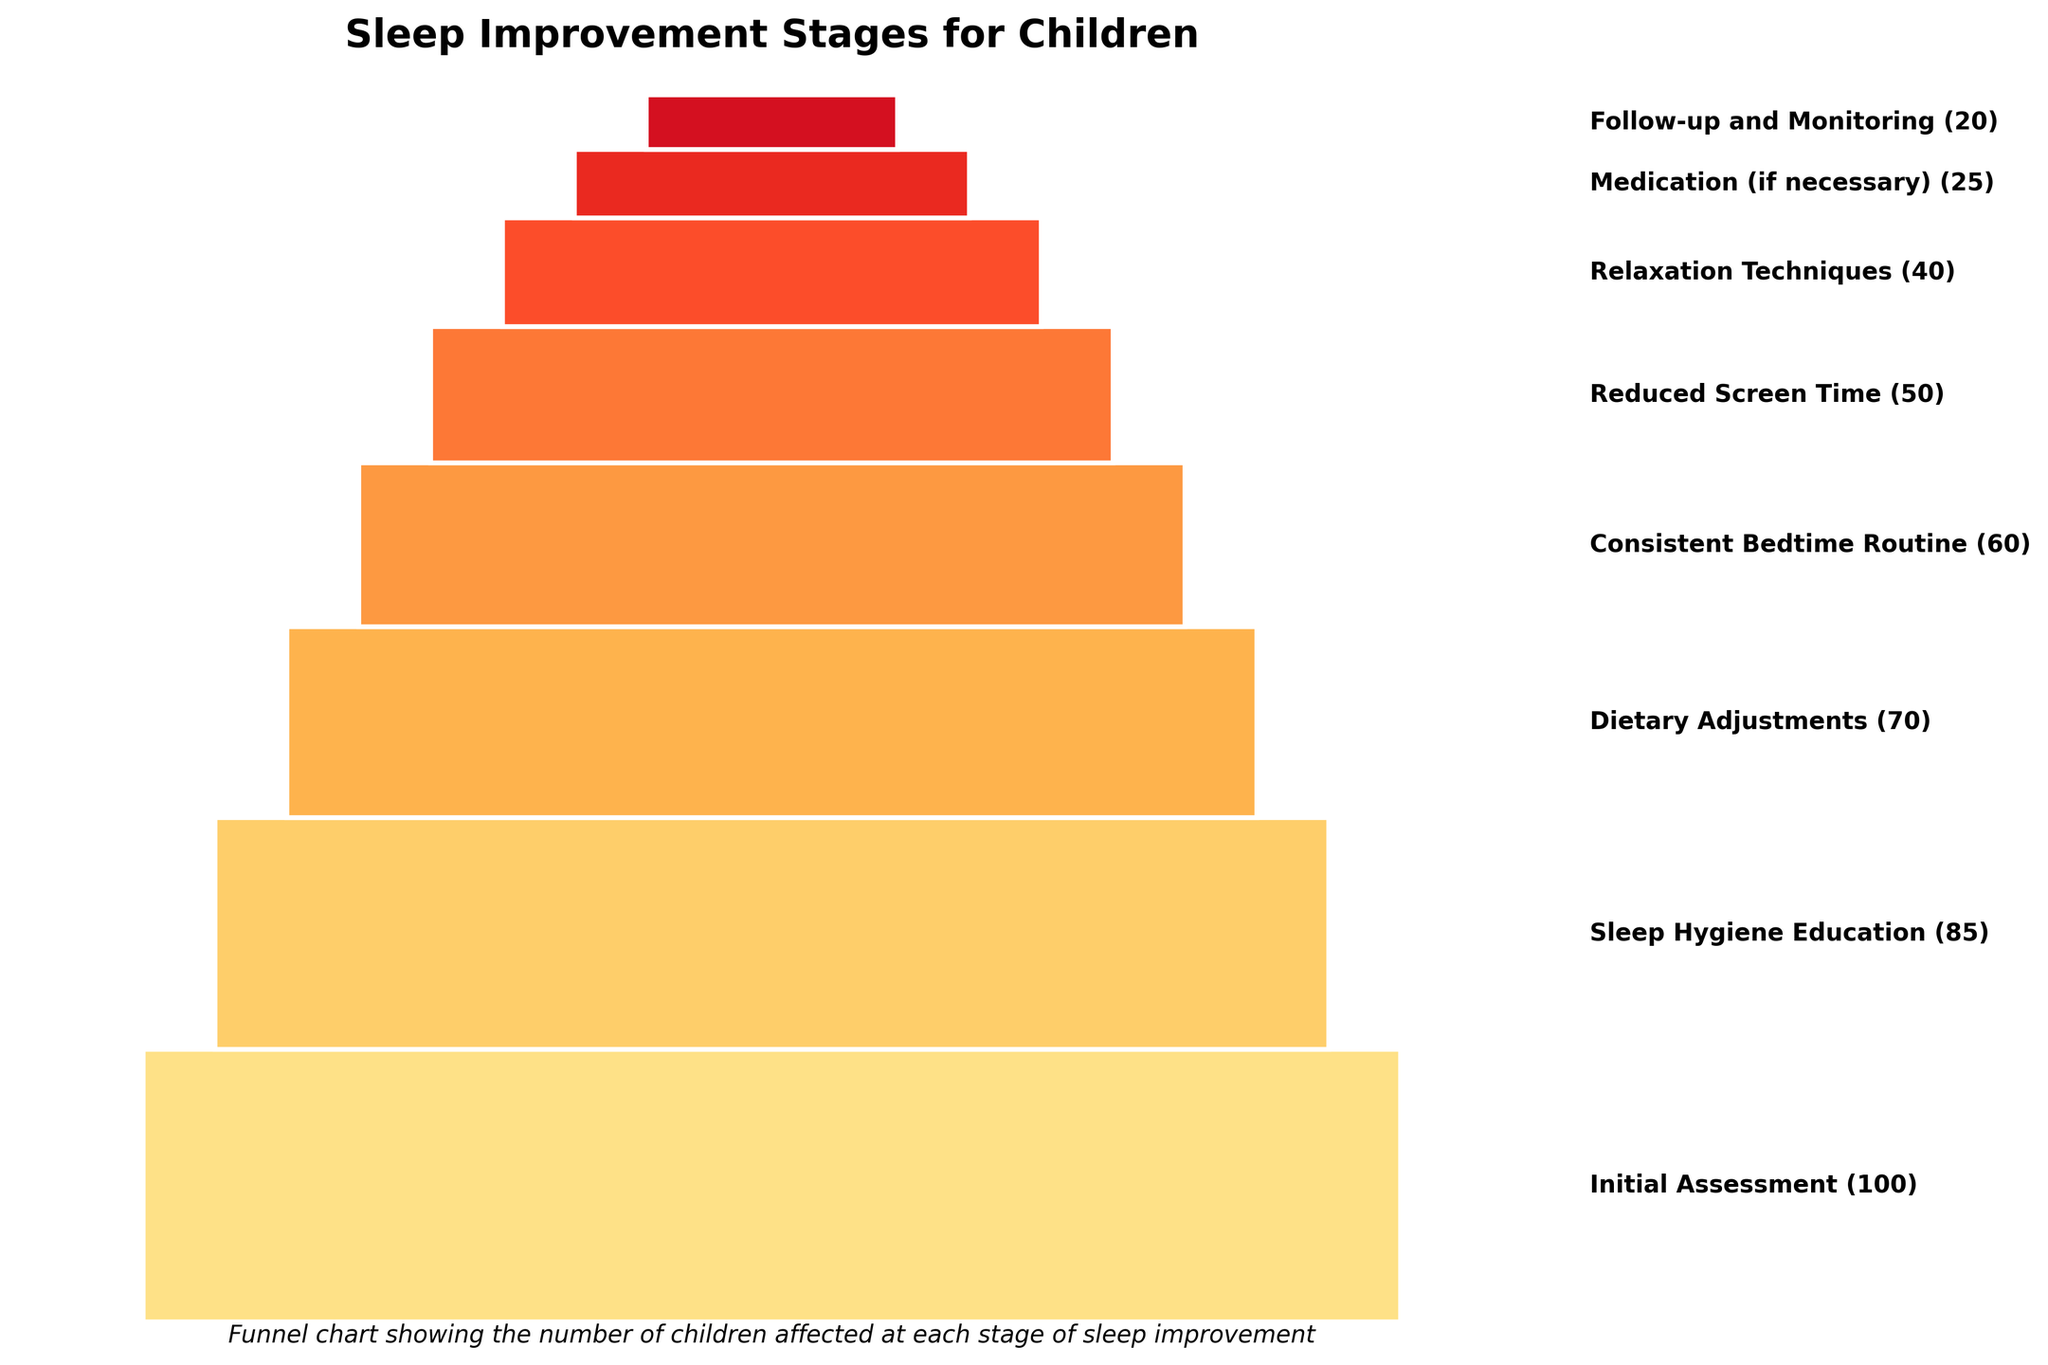What is the title of the figure? The title of the figure is displayed prominently at the top of the chart. It reads "Sleep Improvement Stages for Children".
Answer: Sleep Improvement Stages for Children How many stages are depicted in the figure? By counting the number of distinct segments in the funnel chart, we can determine that there are 8 stages depicted in the figure.
Answer: 8 What is the first stage of sleep improvement and how many children are affected at this stage? The first stage is indicated at the topmost segment of the funnel chart. It is labeled "Initial Assessment" and affects 100 children.
Answer: Initial Assessment (100) Which stage shows the greatest drop in the number of children affected compared to the previous stage? By examining the differences between consecutive stages, we can identify the stage with the largest drop. The greatest drop is between "Medication (if necessary)" with 25 children and the following stage "Follow-up and Monitoring" with 20 children, a difference of 5.
Answer: Medication (if necessary) to Follow-up and Monitoring What is the combined number of children affected in the last three stages? To find the total number of children in the last three stages, sum the affected children in "Relaxation Techniques" (40), "Medication (if necessary)" (25), and "Follow-up and Monitoring" (20): 40 + 25 + 20 = 85.
Answer: 85 Which two stages have the closest number of children affected? By comparing the values, the stages "Sleep Hygiene Education" with 85 children and "Dietary Adjustments" with 70 children have a difference of 15, which is less than the differences between other stages.
Answer: Sleep Hygiene Education and Dietary Adjustments Which stage has the least amount of children affected and how many children are affected in this stage? The lowest segment of the funnel chart represents the stage with the least children affected. This stage is "Follow-up and Monitoring" with 20 children.
Answer: Follow-up and Monitoring (20) How many more children are affected in the "Sleep Hygiene Education" stage compared to the "Reduced Screen Time" stage? The number of children in the "Sleep Hygiene Education" stage is 85, and in the "Reduced Screen Time" stage is 50. The difference is 85 - 50 = 35.
Answer: 35 What is the cumulative number of children affected from the "Initial Assessment" to the "Consistent Bedtime Routine" stage? Sum the number of children from "Initial Assessment" (100), "Sleep Hygiene Education" (85), "Dietary Adjustments" (70), and "Consistent Bedtime Routine" (60): 100 + 85 + 70 + 60 = 315.
Answer: 315 Which stage has half the number of children affected compared to the "Dietary Adjustments" stage? The "Dietary Adjustments" stage has 70 children affected. Half of 70 is 35. The stage "Relaxation Techniques" has 40 children affected, which is the closest to 35.
Answer: Relaxation Techniques 